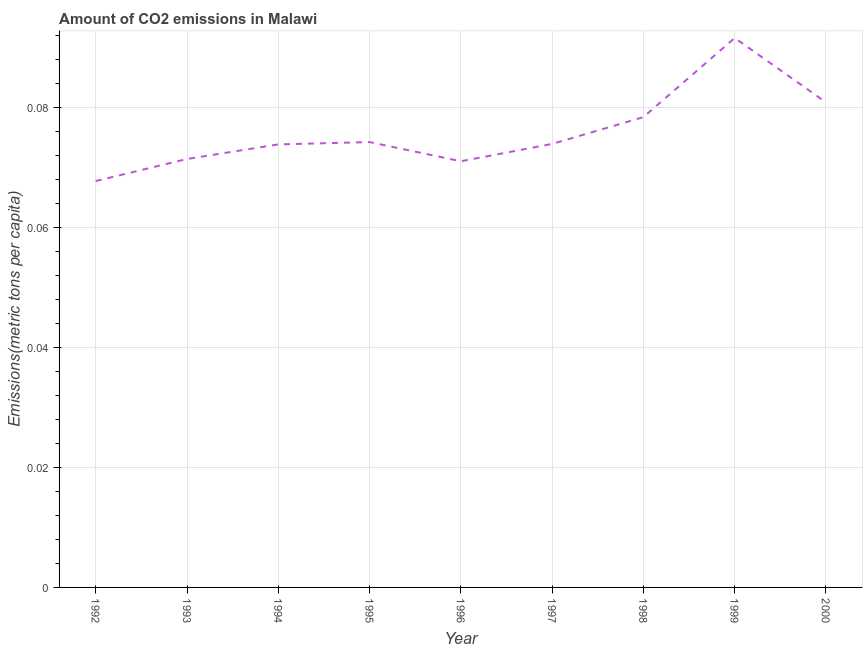What is the amount of co2 emissions in 1994?
Make the answer very short. 0.07. Across all years, what is the maximum amount of co2 emissions?
Offer a very short reply. 0.09. Across all years, what is the minimum amount of co2 emissions?
Offer a very short reply. 0.07. In which year was the amount of co2 emissions maximum?
Your answer should be very brief. 1999. What is the sum of the amount of co2 emissions?
Keep it short and to the point. 0.68. What is the difference between the amount of co2 emissions in 1992 and 1993?
Your answer should be compact. -0. What is the average amount of co2 emissions per year?
Give a very brief answer. 0.08. What is the median amount of co2 emissions?
Make the answer very short. 0.07. In how many years, is the amount of co2 emissions greater than 0.072 metric tons per capita?
Offer a very short reply. 6. What is the ratio of the amount of co2 emissions in 1992 to that in 1997?
Make the answer very short. 0.92. Is the amount of co2 emissions in 1999 less than that in 2000?
Ensure brevity in your answer.  No. What is the difference between the highest and the second highest amount of co2 emissions?
Offer a very short reply. 0.01. What is the difference between the highest and the lowest amount of co2 emissions?
Ensure brevity in your answer.  0.02. In how many years, is the amount of co2 emissions greater than the average amount of co2 emissions taken over all years?
Give a very brief answer. 3. Does the amount of co2 emissions monotonically increase over the years?
Offer a terse response. No. Are the values on the major ticks of Y-axis written in scientific E-notation?
Offer a very short reply. No. Does the graph contain any zero values?
Give a very brief answer. No. What is the title of the graph?
Provide a succinct answer. Amount of CO2 emissions in Malawi. What is the label or title of the X-axis?
Provide a succinct answer. Year. What is the label or title of the Y-axis?
Provide a succinct answer. Emissions(metric tons per capita). What is the Emissions(metric tons per capita) in 1992?
Provide a short and direct response. 0.07. What is the Emissions(metric tons per capita) in 1993?
Provide a succinct answer. 0.07. What is the Emissions(metric tons per capita) in 1994?
Provide a short and direct response. 0.07. What is the Emissions(metric tons per capita) in 1995?
Give a very brief answer. 0.07. What is the Emissions(metric tons per capita) in 1996?
Keep it short and to the point. 0.07. What is the Emissions(metric tons per capita) in 1997?
Provide a succinct answer. 0.07. What is the Emissions(metric tons per capita) in 1998?
Keep it short and to the point. 0.08. What is the Emissions(metric tons per capita) of 1999?
Keep it short and to the point. 0.09. What is the Emissions(metric tons per capita) in 2000?
Your answer should be very brief. 0.08. What is the difference between the Emissions(metric tons per capita) in 1992 and 1993?
Your answer should be compact. -0. What is the difference between the Emissions(metric tons per capita) in 1992 and 1994?
Offer a terse response. -0.01. What is the difference between the Emissions(metric tons per capita) in 1992 and 1995?
Offer a terse response. -0.01. What is the difference between the Emissions(metric tons per capita) in 1992 and 1996?
Keep it short and to the point. -0. What is the difference between the Emissions(metric tons per capita) in 1992 and 1997?
Ensure brevity in your answer.  -0.01. What is the difference between the Emissions(metric tons per capita) in 1992 and 1998?
Your answer should be very brief. -0.01. What is the difference between the Emissions(metric tons per capita) in 1992 and 1999?
Give a very brief answer. -0.02. What is the difference between the Emissions(metric tons per capita) in 1992 and 2000?
Provide a short and direct response. -0.01. What is the difference between the Emissions(metric tons per capita) in 1993 and 1994?
Provide a succinct answer. -0. What is the difference between the Emissions(metric tons per capita) in 1993 and 1995?
Give a very brief answer. -0. What is the difference between the Emissions(metric tons per capita) in 1993 and 1996?
Make the answer very short. 0. What is the difference between the Emissions(metric tons per capita) in 1993 and 1997?
Your response must be concise. -0. What is the difference between the Emissions(metric tons per capita) in 1993 and 1998?
Offer a terse response. -0.01. What is the difference between the Emissions(metric tons per capita) in 1993 and 1999?
Give a very brief answer. -0.02. What is the difference between the Emissions(metric tons per capita) in 1993 and 2000?
Offer a very short reply. -0.01. What is the difference between the Emissions(metric tons per capita) in 1994 and 1995?
Make the answer very short. -0. What is the difference between the Emissions(metric tons per capita) in 1994 and 1996?
Offer a very short reply. 0. What is the difference between the Emissions(metric tons per capita) in 1994 and 1997?
Your answer should be very brief. -8e-5. What is the difference between the Emissions(metric tons per capita) in 1994 and 1998?
Make the answer very short. -0. What is the difference between the Emissions(metric tons per capita) in 1994 and 1999?
Make the answer very short. -0.02. What is the difference between the Emissions(metric tons per capita) in 1994 and 2000?
Keep it short and to the point. -0.01. What is the difference between the Emissions(metric tons per capita) in 1995 and 1996?
Provide a short and direct response. 0. What is the difference between the Emissions(metric tons per capita) in 1995 and 1997?
Your response must be concise. 0. What is the difference between the Emissions(metric tons per capita) in 1995 and 1998?
Your answer should be very brief. -0. What is the difference between the Emissions(metric tons per capita) in 1995 and 1999?
Offer a very short reply. -0.02. What is the difference between the Emissions(metric tons per capita) in 1995 and 2000?
Give a very brief answer. -0.01. What is the difference between the Emissions(metric tons per capita) in 1996 and 1997?
Ensure brevity in your answer.  -0. What is the difference between the Emissions(metric tons per capita) in 1996 and 1998?
Provide a short and direct response. -0.01. What is the difference between the Emissions(metric tons per capita) in 1996 and 1999?
Your answer should be compact. -0.02. What is the difference between the Emissions(metric tons per capita) in 1996 and 2000?
Your answer should be compact. -0.01. What is the difference between the Emissions(metric tons per capita) in 1997 and 1998?
Offer a terse response. -0. What is the difference between the Emissions(metric tons per capita) in 1997 and 1999?
Your answer should be very brief. -0.02. What is the difference between the Emissions(metric tons per capita) in 1997 and 2000?
Provide a short and direct response. -0.01. What is the difference between the Emissions(metric tons per capita) in 1998 and 1999?
Your answer should be very brief. -0.01. What is the difference between the Emissions(metric tons per capita) in 1998 and 2000?
Give a very brief answer. -0. What is the difference between the Emissions(metric tons per capita) in 1999 and 2000?
Provide a short and direct response. 0.01. What is the ratio of the Emissions(metric tons per capita) in 1992 to that in 1993?
Your answer should be compact. 0.95. What is the ratio of the Emissions(metric tons per capita) in 1992 to that in 1994?
Provide a succinct answer. 0.92. What is the ratio of the Emissions(metric tons per capita) in 1992 to that in 1995?
Your answer should be compact. 0.91. What is the ratio of the Emissions(metric tons per capita) in 1992 to that in 1996?
Your answer should be compact. 0.95. What is the ratio of the Emissions(metric tons per capita) in 1992 to that in 1997?
Provide a succinct answer. 0.92. What is the ratio of the Emissions(metric tons per capita) in 1992 to that in 1998?
Provide a short and direct response. 0.86. What is the ratio of the Emissions(metric tons per capita) in 1992 to that in 1999?
Give a very brief answer. 0.74. What is the ratio of the Emissions(metric tons per capita) in 1992 to that in 2000?
Ensure brevity in your answer.  0.84. What is the ratio of the Emissions(metric tons per capita) in 1993 to that in 1998?
Provide a succinct answer. 0.91. What is the ratio of the Emissions(metric tons per capita) in 1993 to that in 1999?
Your response must be concise. 0.78. What is the ratio of the Emissions(metric tons per capita) in 1993 to that in 2000?
Provide a succinct answer. 0.88. What is the ratio of the Emissions(metric tons per capita) in 1994 to that in 1998?
Ensure brevity in your answer.  0.94. What is the ratio of the Emissions(metric tons per capita) in 1994 to that in 1999?
Your answer should be very brief. 0.81. What is the ratio of the Emissions(metric tons per capita) in 1994 to that in 2000?
Offer a very short reply. 0.91. What is the ratio of the Emissions(metric tons per capita) in 1995 to that in 1996?
Keep it short and to the point. 1.04. What is the ratio of the Emissions(metric tons per capita) in 1995 to that in 1998?
Your response must be concise. 0.95. What is the ratio of the Emissions(metric tons per capita) in 1995 to that in 1999?
Keep it short and to the point. 0.81. What is the ratio of the Emissions(metric tons per capita) in 1995 to that in 2000?
Ensure brevity in your answer.  0.92. What is the ratio of the Emissions(metric tons per capita) in 1996 to that in 1997?
Make the answer very short. 0.96. What is the ratio of the Emissions(metric tons per capita) in 1996 to that in 1998?
Keep it short and to the point. 0.91. What is the ratio of the Emissions(metric tons per capita) in 1996 to that in 1999?
Make the answer very short. 0.78. What is the ratio of the Emissions(metric tons per capita) in 1996 to that in 2000?
Ensure brevity in your answer.  0.88. What is the ratio of the Emissions(metric tons per capita) in 1997 to that in 1998?
Keep it short and to the point. 0.94. What is the ratio of the Emissions(metric tons per capita) in 1997 to that in 1999?
Give a very brief answer. 0.81. What is the ratio of the Emissions(metric tons per capita) in 1997 to that in 2000?
Your answer should be compact. 0.91. What is the ratio of the Emissions(metric tons per capita) in 1998 to that in 1999?
Ensure brevity in your answer.  0.86. What is the ratio of the Emissions(metric tons per capita) in 1998 to that in 2000?
Make the answer very short. 0.97. What is the ratio of the Emissions(metric tons per capita) in 1999 to that in 2000?
Ensure brevity in your answer.  1.13. 